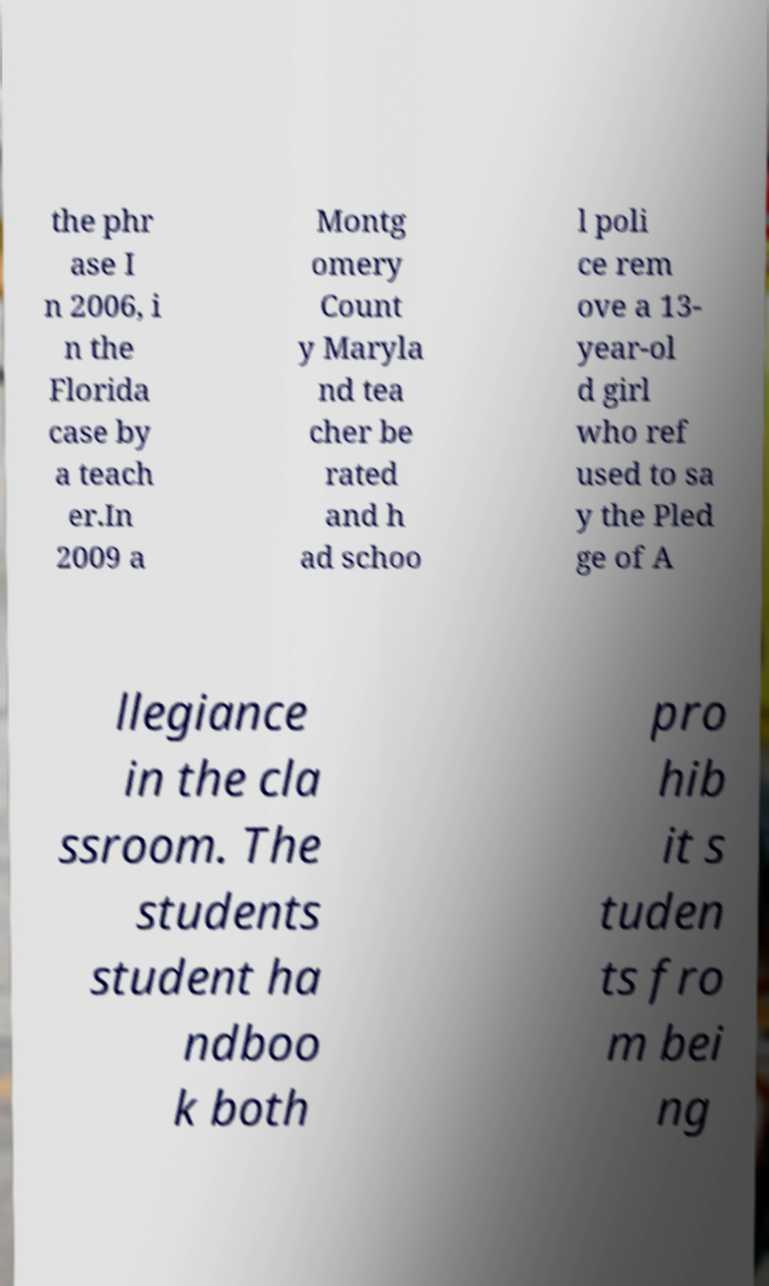Please identify and transcribe the text found in this image. the phr ase I n 2006, i n the Florida case by a teach er.In 2009 a Montg omery Count y Maryla nd tea cher be rated and h ad schoo l poli ce rem ove a 13- year-ol d girl who ref used to sa y the Pled ge of A llegiance in the cla ssroom. The students student ha ndboo k both pro hib it s tuden ts fro m bei ng 